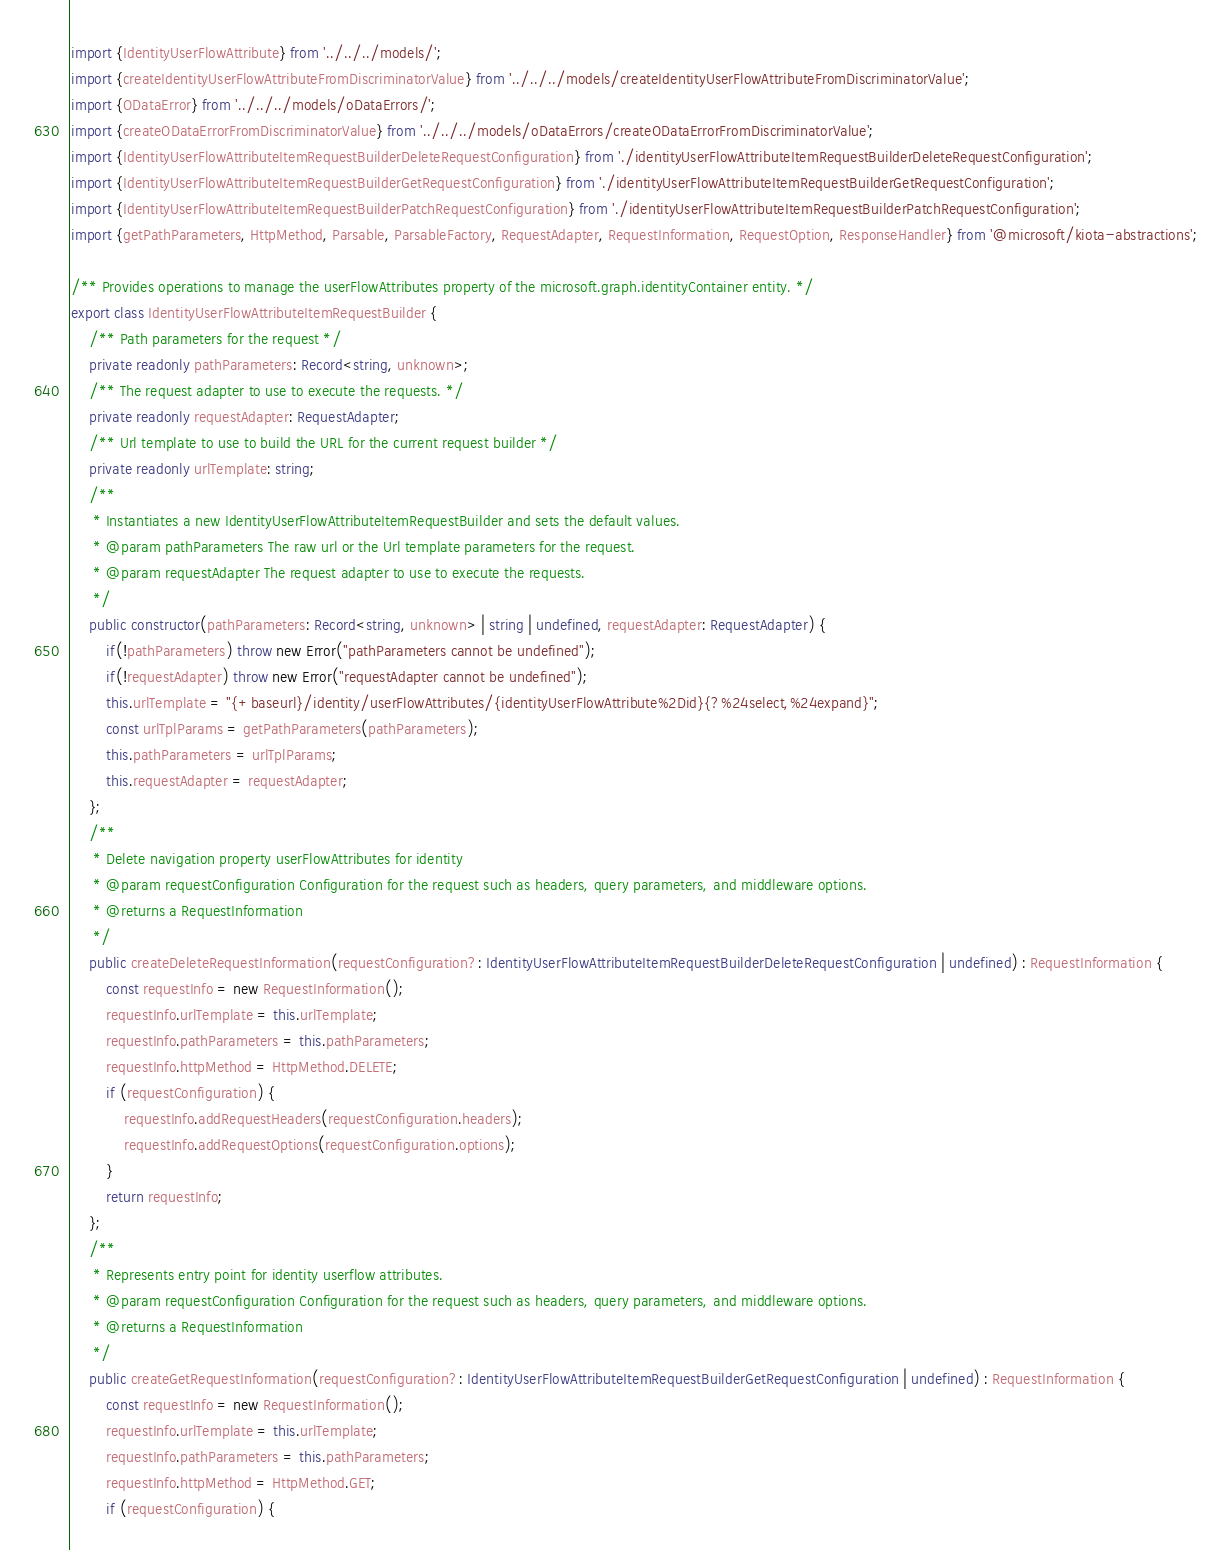Convert code to text. <code><loc_0><loc_0><loc_500><loc_500><_TypeScript_>import {IdentityUserFlowAttribute} from '../../../models/';
import {createIdentityUserFlowAttributeFromDiscriminatorValue} from '../../../models/createIdentityUserFlowAttributeFromDiscriminatorValue';
import {ODataError} from '../../../models/oDataErrors/';
import {createODataErrorFromDiscriminatorValue} from '../../../models/oDataErrors/createODataErrorFromDiscriminatorValue';
import {IdentityUserFlowAttributeItemRequestBuilderDeleteRequestConfiguration} from './identityUserFlowAttributeItemRequestBuilderDeleteRequestConfiguration';
import {IdentityUserFlowAttributeItemRequestBuilderGetRequestConfiguration} from './identityUserFlowAttributeItemRequestBuilderGetRequestConfiguration';
import {IdentityUserFlowAttributeItemRequestBuilderPatchRequestConfiguration} from './identityUserFlowAttributeItemRequestBuilderPatchRequestConfiguration';
import {getPathParameters, HttpMethod, Parsable, ParsableFactory, RequestAdapter, RequestInformation, RequestOption, ResponseHandler} from '@microsoft/kiota-abstractions';

/** Provides operations to manage the userFlowAttributes property of the microsoft.graph.identityContainer entity. */
export class IdentityUserFlowAttributeItemRequestBuilder {
    /** Path parameters for the request */
    private readonly pathParameters: Record<string, unknown>;
    /** The request adapter to use to execute the requests. */
    private readonly requestAdapter: RequestAdapter;
    /** Url template to use to build the URL for the current request builder */
    private readonly urlTemplate: string;
    /**
     * Instantiates a new IdentityUserFlowAttributeItemRequestBuilder and sets the default values.
     * @param pathParameters The raw url or the Url template parameters for the request.
     * @param requestAdapter The request adapter to use to execute the requests.
     */
    public constructor(pathParameters: Record<string, unknown> | string | undefined, requestAdapter: RequestAdapter) {
        if(!pathParameters) throw new Error("pathParameters cannot be undefined");
        if(!requestAdapter) throw new Error("requestAdapter cannot be undefined");
        this.urlTemplate = "{+baseurl}/identity/userFlowAttributes/{identityUserFlowAttribute%2Did}{?%24select,%24expand}";
        const urlTplParams = getPathParameters(pathParameters);
        this.pathParameters = urlTplParams;
        this.requestAdapter = requestAdapter;
    };
    /**
     * Delete navigation property userFlowAttributes for identity
     * @param requestConfiguration Configuration for the request such as headers, query parameters, and middleware options.
     * @returns a RequestInformation
     */
    public createDeleteRequestInformation(requestConfiguration?: IdentityUserFlowAttributeItemRequestBuilderDeleteRequestConfiguration | undefined) : RequestInformation {
        const requestInfo = new RequestInformation();
        requestInfo.urlTemplate = this.urlTemplate;
        requestInfo.pathParameters = this.pathParameters;
        requestInfo.httpMethod = HttpMethod.DELETE;
        if (requestConfiguration) {
            requestInfo.addRequestHeaders(requestConfiguration.headers);
            requestInfo.addRequestOptions(requestConfiguration.options);
        }
        return requestInfo;
    };
    /**
     * Represents entry point for identity userflow attributes.
     * @param requestConfiguration Configuration for the request such as headers, query parameters, and middleware options.
     * @returns a RequestInformation
     */
    public createGetRequestInformation(requestConfiguration?: IdentityUserFlowAttributeItemRequestBuilderGetRequestConfiguration | undefined) : RequestInformation {
        const requestInfo = new RequestInformation();
        requestInfo.urlTemplate = this.urlTemplate;
        requestInfo.pathParameters = this.pathParameters;
        requestInfo.httpMethod = HttpMethod.GET;
        if (requestConfiguration) {</code> 